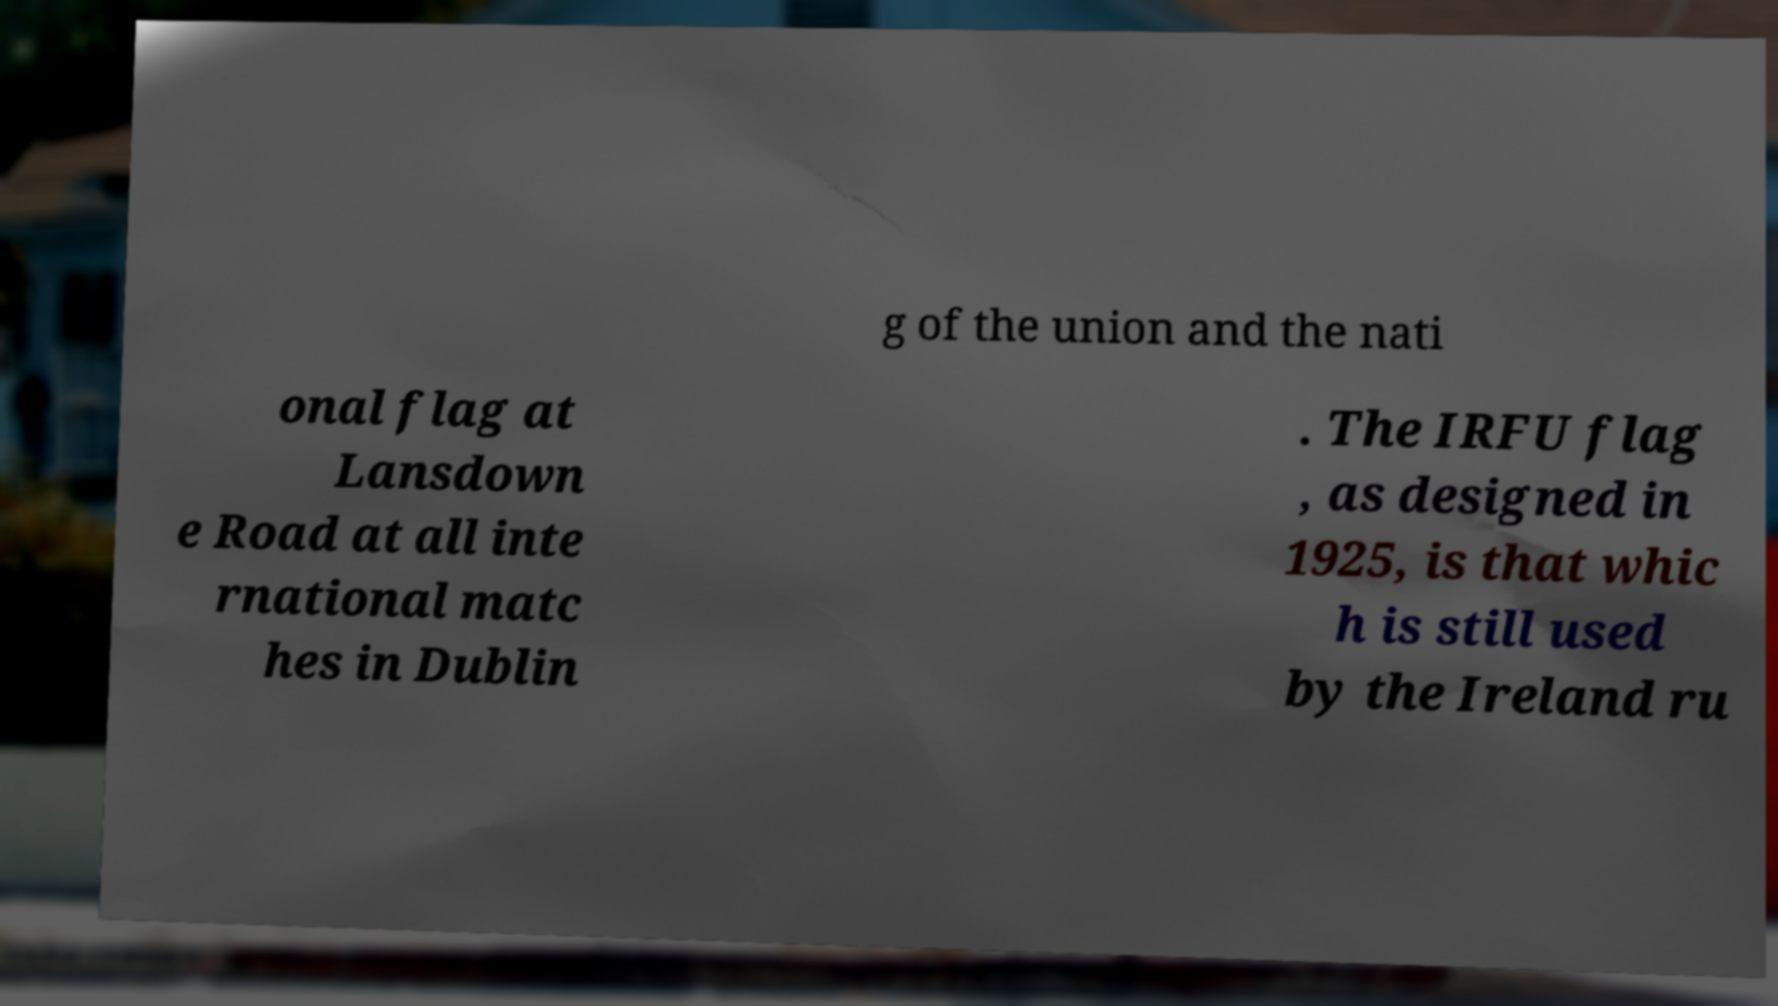There's text embedded in this image that I need extracted. Can you transcribe it verbatim? g of the union and the nati onal flag at Lansdown e Road at all inte rnational matc hes in Dublin . The IRFU flag , as designed in 1925, is that whic h is still used by the Ireland ru 